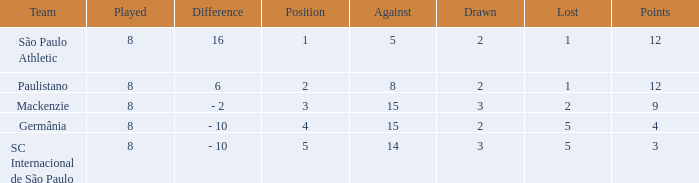What was the position with the total number less than 1? 0.0. 